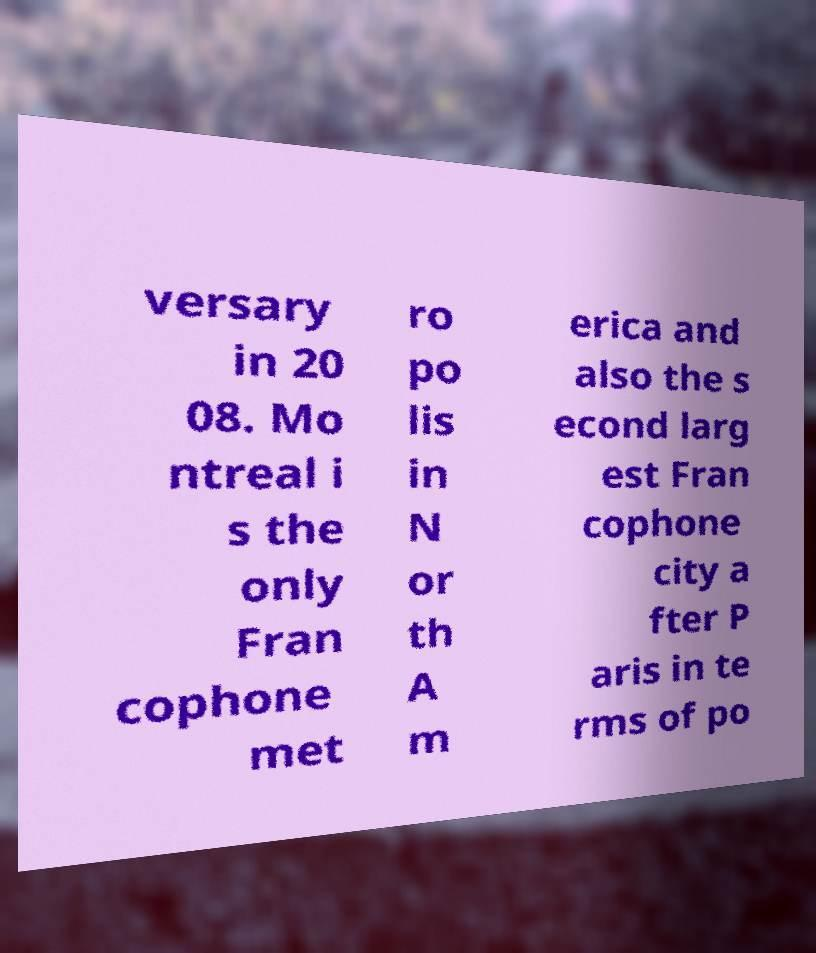Can you read and provide the text displayed in the image?This photo seems to have some interesting text. Can you extract and type it out for me? versary in 20 08. Mo ntreal i s the only Fran cophone met ro po lis in N or th A m erica and also the s econd larg est Fran cophone city a fter P aris in te rms of po 